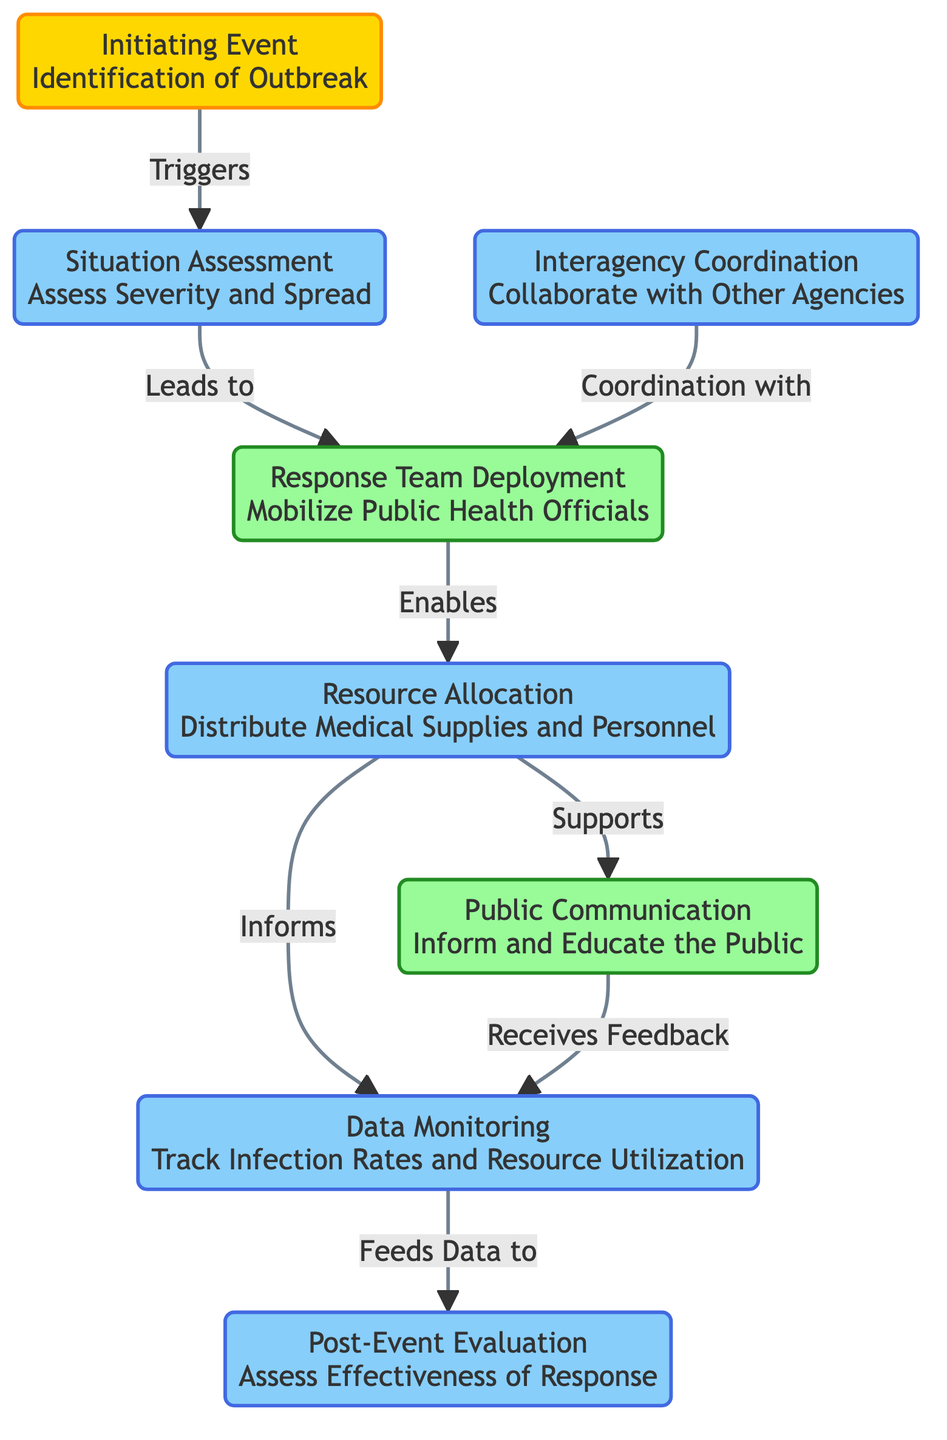What triggers the situation assessment? The initiating event, identified as the "Identification of Outbreak," triggers the situation assessment in the diagram. This is indicated by the arrow showing the flow from the initiating event to the situation assessment.
Answer: initiating event How many processes are represented in the diagram? The diagram contains six processes: Situation Assessment, Resource Allocation, Interagency Coordination, Data Monitoring, Evaluation, and the Response Team Deployment, all of which are categorized under processes as indicated by their color and labels.
Answer: six What does the response team deployment enable? The response team deployment enables resource allocation, as indicated in the diagram by the arrow connecting the response team to resource allocation.
Answer: resource allocation Which node supports public communication? The resource allocation node supports public communication, as the flow indicated by the arrow in the diagram shows a direct connection from resource allocation to public communication.
Answer: resource allocation What provides feedback to data monitoring? Public communication provides feedback to data monitoring. The diagram has an arrow showing the relationship from public communication to data monitoring, indicating this feedback loop.
Answer: public communication Which two nodes are connected by interagency coordination? Interagency coordination is connected with the response team. The diagram shows an arrow leading from the interagency coordination node to the response team node, indicating their collaboration.
Answer: response team What is assessed in the post-event evaluation? The post-event evaluation assesses the effectiveness of the response. The diagram clearly labels this evaluation, pointing to what is being assessed in this phase.
Answer: effectiveness of response How does resource allocation inform data monitoring? Resource allocation informs data monitoring by providing necessary data regarding the distribution of resources and their utilization, as shown by the connecting arrow in the diagram.
Answer: by providing data What is the primary action after identifying an outbreak? The primary action following the identification of an outbreak is the situation assessment. The diagram reflects this flow with a direct link from the initiating event to the situation assessment node.
Answer: situation assessment 